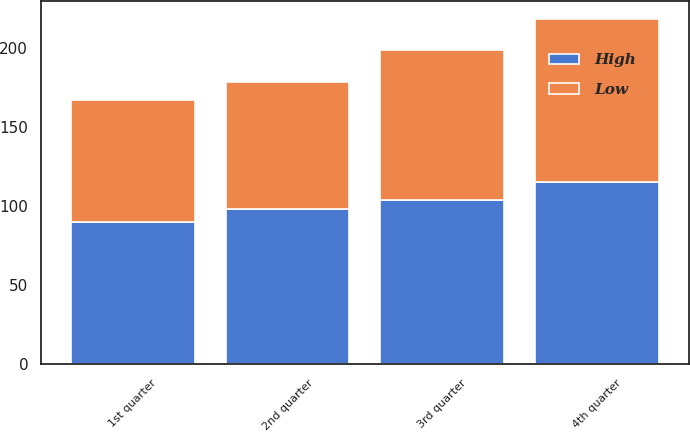<chart> <loc_0><loc_0><loc_500><loc_500><stacked_bar_chart><ecel><fcel>1st quarter<fcel>2nd quarter<fcel>3rd quarter<fcel>4th quarter<nl><fcel>High<fcel>90.17<fcel>98.21<fcel>103.61<fcel>114.98<nl><fcel>Low<fcel>77.13<fcel>80.23<fcel>94.8<fcel>103.44<nl></chart> 